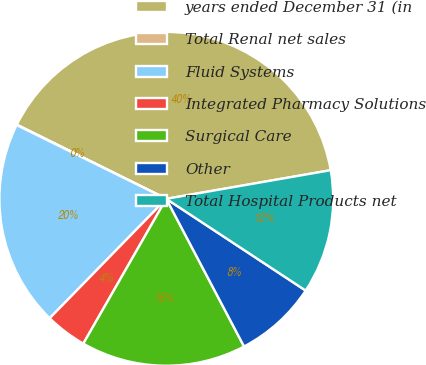Convert chart. <chart><loc_0><loc_0><loc_500><loc_500><pie_chart><fcel>years ended December 31 (in<fcel>Total Renal net sales<fcel>Fluid Systems<fcel>Integrated Pharmacy Solutions<fcel>Surgical Care<fcel>Other<fcel>Total Hospital Products net<nl><fcel>39.93%<fcel>0.04%<fcel>19.98%<fcel>4.03%<fcel>16.0%<fcel>8.02%<fcel>12.01%<nl></chart> 